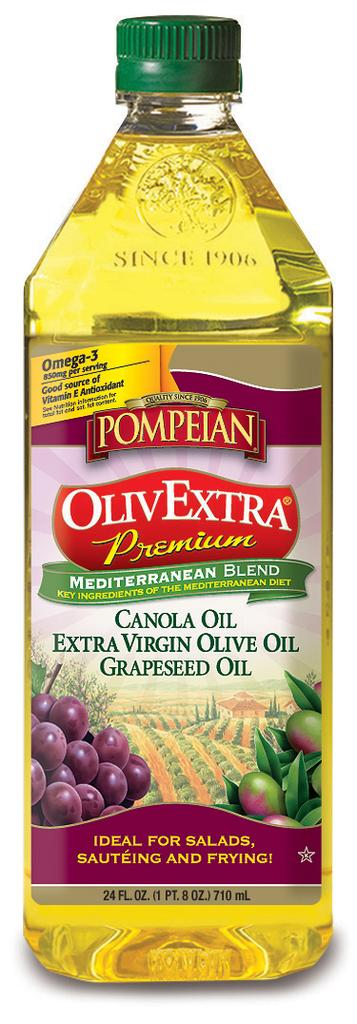What object is present in the image? There is an oil bottle in the image. What feature of the oil bottle is mentioned in the facts? The oil bottle has a label and a cap. What grade of chicken is depicted on the oil bottle? There is no chicken depicted on the oil bottle; it is an oil bottle with a label and a cap. 